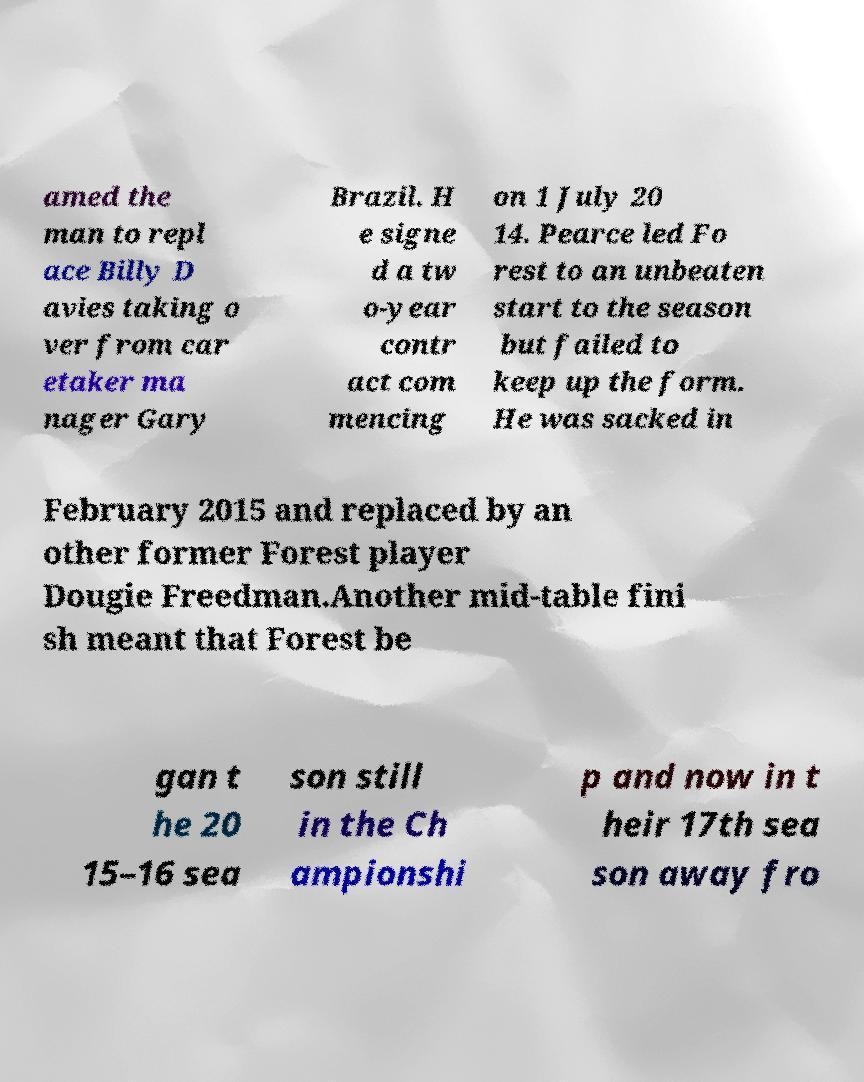Could you extract and type out the text from this image? amed the man to repl ace Billy D avies taking o ver from car etaker ma nager Gary Brazil. H e signe d a tw o-year contr act com mencing on 1 July 20 14. Pearce led Fo rest to an unbeaten start to the season but failed to keep up the form. He was sacked in February 2015 and replaced by an other former Forest player Dougie Freedman.Another mid-table fini sh meant that Forest be gan t he 20 15–16 sea son still in the Ch ampionshi p and now in t heir 17th sea son away fro 